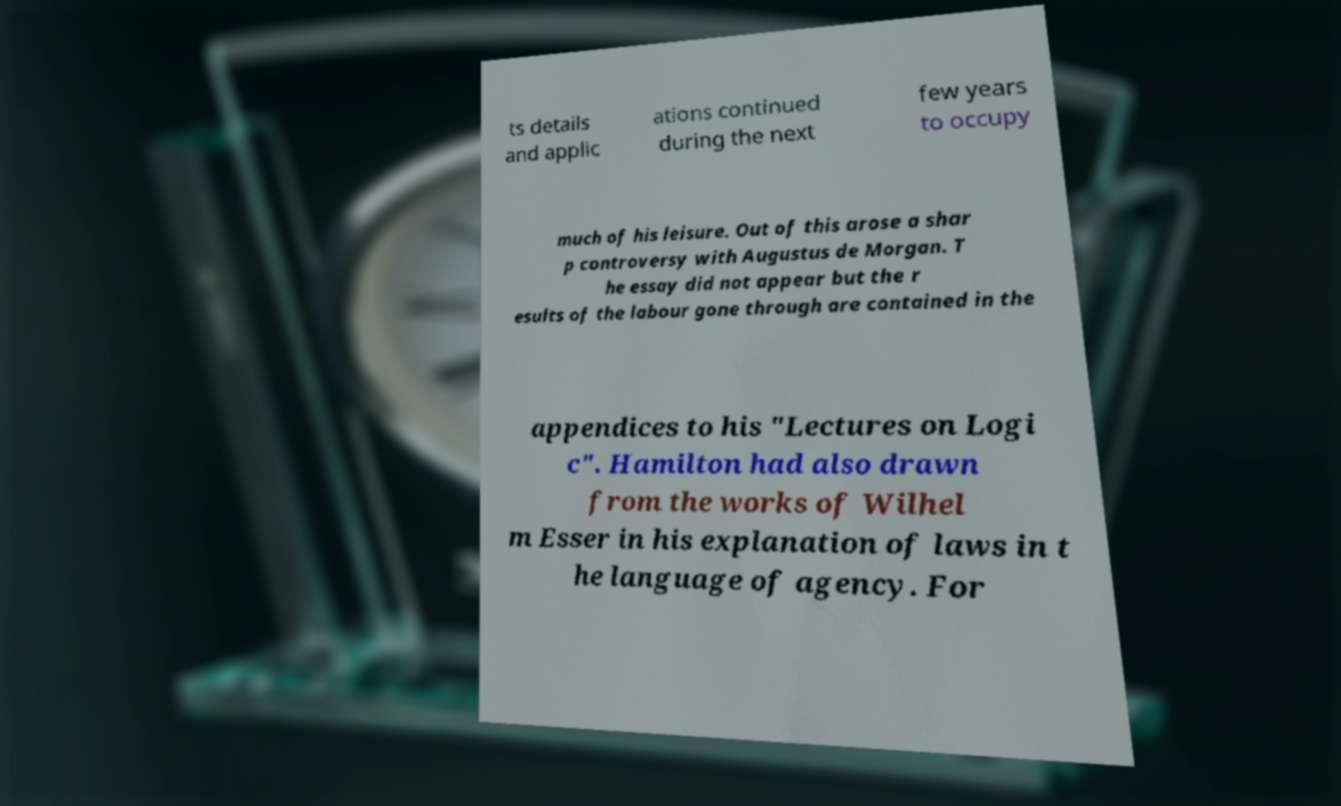There's text embedded in this image that I need extracted. Can you transcribe it verbatim? ts details and applic ations continued during the next few years to occupy much of his leisure. Out of this arose a shar p controversy with Augustus de Morgan. T he essay did not appear but the r esults of the labour gone through are contained in the appendices to his "Lectures on Logi c". Hamilton had also drawn from the works of Wilhel m Esser in his explanation of laws in t he language of agency. For 